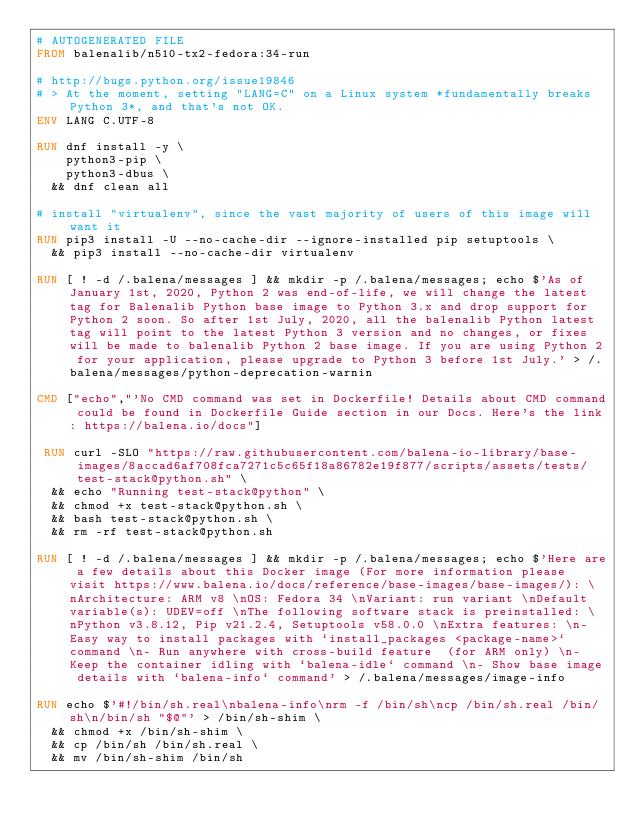Convert code to text. <code><loc_0><loc_0><loc_500><loc_500><_Dockerfile_># AUTOGENERATED FILE
FROM balenalib/n510-tx2-fedora:34-run

# http://bugs.python.org/issue19846
# > At the moment, setting "LANG=C" on a Linux system *fundamentally breaks Python 3*, and that's not OK.
ENV LANG C.UTF-8

RUN dnf install -y \
		python3-pip \
		python3-dbus \
	&& dnf clean all

# install "virtualenv", since the vast majority of users of this image will want it
RUN pip3 install -U --no-cache-dir --ignore-installed pip setuptools \
	&& pip3 install --no-cache-dir virtualenv

RUN [ ! -d /.balena/messages ] && mkdir -p /.balena/messages; echo $'As of January 1st, 2020, Python 2 was end-of-life, we will change the latest tag for Balenalib Python base image to Python 3.x and drop support for Python 2 soon. So after 1st July, 2020, all the balenalib Python latest tag will point to the latest Python 3 version and no changes, or fixes will be made to balenalib Python 2 base image. If you are using Python 2 for your application, please upgrade to Python 3 before 1st July.' > /.balena/messages/python-deprecation-warnin

CMD ["echo","'No CMD command was set in Dockerfile! Details about CMD command could be found in Dockerfile Guide section in our Docs. Here's the link: https://balena.io/docs"]

 RUN curl -SLO "https://raw.githubusercontent.com/balena-io-library/base-images/8accad6af708fca7271c5c65f18a86782e19f877/scripts/assets/tests/test-stack@python.sh" \
  && echo "Running test-stack@python" \
  && chmod +x test-stack@python.sh \
  && bash test-stack@python.sh \
  && rm -rf test-stack@python.sh 

RUN [ ! -d /.balena/messages ] && mkdir -p /.balena/messages; echo $'Here are a few details about this Docker image (For more information please visit https://www.balena.io/docs/reference/base-images/base-images/): \nArchitecture: ARM v8 \nOS: Fedora 34 \nVariant: run variant \nDefault variable(s): UDEV=off \nThe following software stack is preinstalled: \nPython v3.8.12, Pip v21.2.4, Setuptools v58.0.0 \nExtra features: \n- Easy way to install packages with `install_packages <package-name>` command \n- Run anywhere with cross-build feature  (for ARM only) \n- Keep the container idling with `balena-idle` command \n- Show base image details with `balena-info` command' > /.balena/messages/image-info

RUN echo $'#!/bin/sh.real\nbalena-info\nrm -f /bin/sh\ncp /bin/sh.real /bin/sh\n/bin/sh "$@"' > /bin/sh-shim \
	&& chmod +x /bin/sh-shim \
	&& cp /bin/sh /bin/sh.real \
	&& mv /bin/sh-shim /bin/sh</code> 